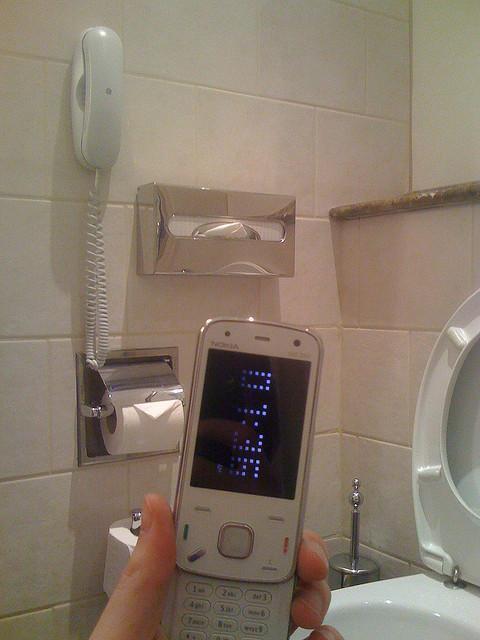How many phones are in the picture?
Give a very brief answer. 1. 